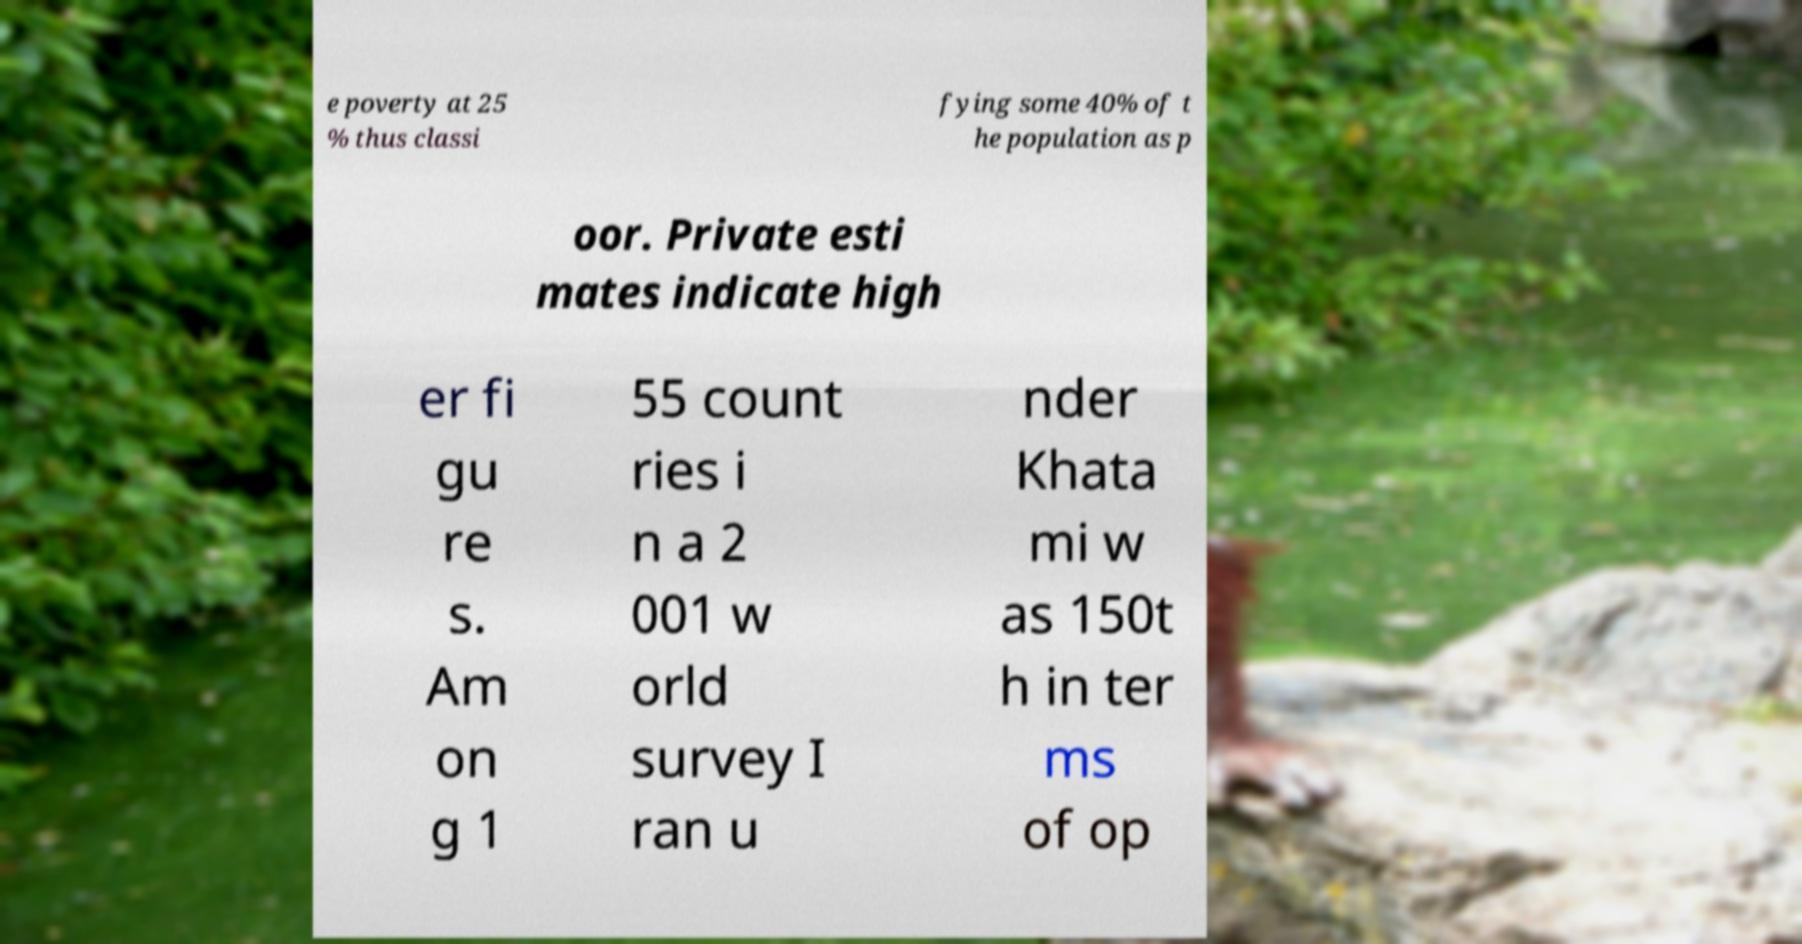What messages or text are displayed in this image? I need them in a readable, typed format. e poverty at 25 % thus classi fying some 40% of t he population as p oor. Private esti mates indicate high er fi gu re s. Am on g 1 55 count ries i n a 2 001 w orld survey I ran u nder Khata mi w as 150t h in ter ms of op 